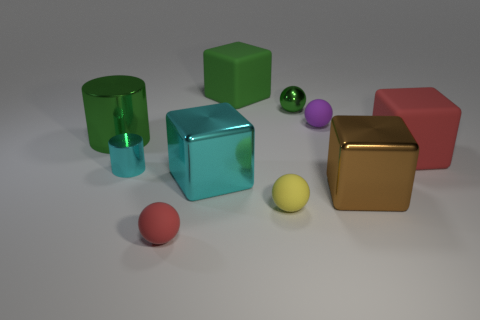Subtract 1 balls. How many balls are left? 3 Subtract all cylinders. How many objects are left? 8 Subtract 1 green balls. How many objects are left? 9 Subtract all big cyan shiny things. Subtract all small purple balls. How many objects are left? 8 Add 1 blocks. How many blocks are left? 5 Add 2 green balls. How many green balls exist? 3 